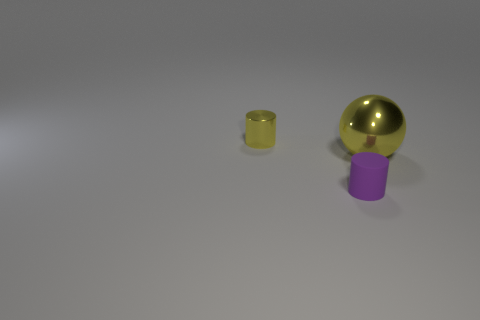Add 2 cyan cylinders. How many objects exist? 5 Subtract all balls. How many objects are left? 2 Subtract 0 blue spheres. How many objects are left? 3 Subtract all tiny gray rubber things. Subtract all purple matte objects. How many objects are left? 2 Add 2 tiny yellow metallic objects. How many tiny yellow metallic objects are left? 3 Add 3 metallic objects. How many metallic objects exist? 5 